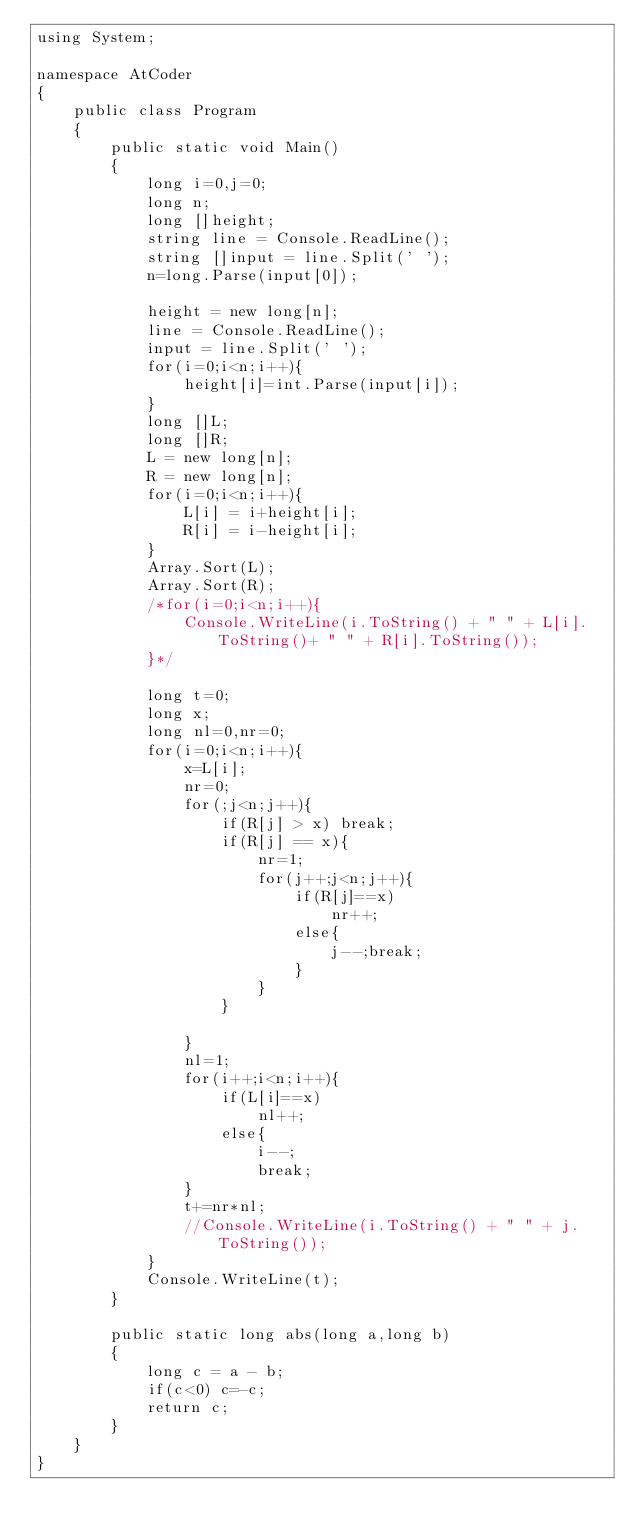Convert code to text. <code><loc_0><loc_0><loc_500><loc_500><_C#_>using System;

namespace AtCoder
{
    public class Program
    {
        public static void Main()
        {
            long i=0,j=0;
            long n;
            long []height;
            string line = Console.ReadLine();
            string []input = line.Split(' ');
            n=long.Parse(input[0]);

            height = new long[n];
            line = Console.ReadLine();
            input = line.Split(' ');
            for(i=0;i<n;i++){
                height[i]=int.Parse(input[i]);
            }
            long []L;
            long []R;
            L = new long[n];
            R = new long[n];
            for(i=0;i<n;i++){
                L[i] = i+height[i];
                R[i] = i-height[i];
            }
            Array.Sort(L);
            Array.Sort(R);
            /*for(i=0;i<n;i++){
                Console.WriteLine(i.ToString() + " " + L[i].ToString()+ " " + R[i].ToString());
            }*/

            long t=0;
            long x;
            long nl=0,nr=0;
            for(i=0;i<n;i++){
                x=L[i];
                nr=0;
                for(;j<n;j++){
                    if(R[j] > x) break;
                    if(R[j] == x){
                        nr=1;
                        for(j++;j<n;j++){
                            if(R[j]==x)
                                nr++;
                            else{
                                j--;break;
                            }
                        }
                    }
                    
                }
                nl=1;
                for(i++;i<n;i++){
                    if(L[i]==x)
                        nl++;
                    else{
                        i--;
                        break;
                }
                t+=nr*nl;
                //Console.WriteLine(i.ToString() + " " + j.ToString());
            }
            Console.WriteLine(t);
        }

        public static long abs(long a,long b)
        {
            long c = a - b;
            if(c<0) c=-c;
            return c;
        }
    }
}</code> 